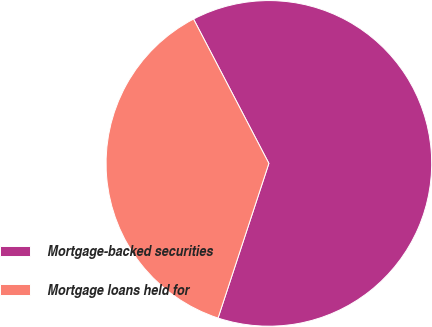Convert chart to OTSL. <chart><loc_0><loc_0><loc_500><loc_500><pie_chart><fcel>Mortgage-backed securities<fcel>Mortgage loans held for<nl><fcel>62.71%<fcel>37.29%<nl></chart> 